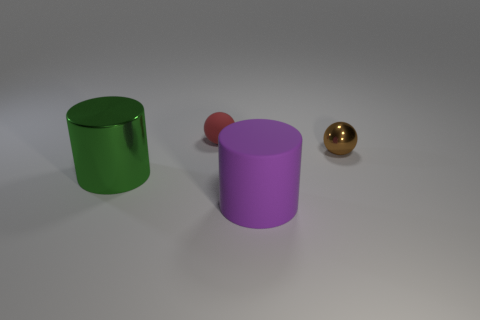Add 4 tiny red things. How many objects exist? 8 Add 4 small brown objects. How many small brown objects are left? 5 Add 1 cyan cylinders. How many cyan cylinders exist? 1 Subtract 0 purple balls. How many objects are left? 4 Subtract all blue rubber balls. Subtract all big green shiny objects. How many objects are left? 3 